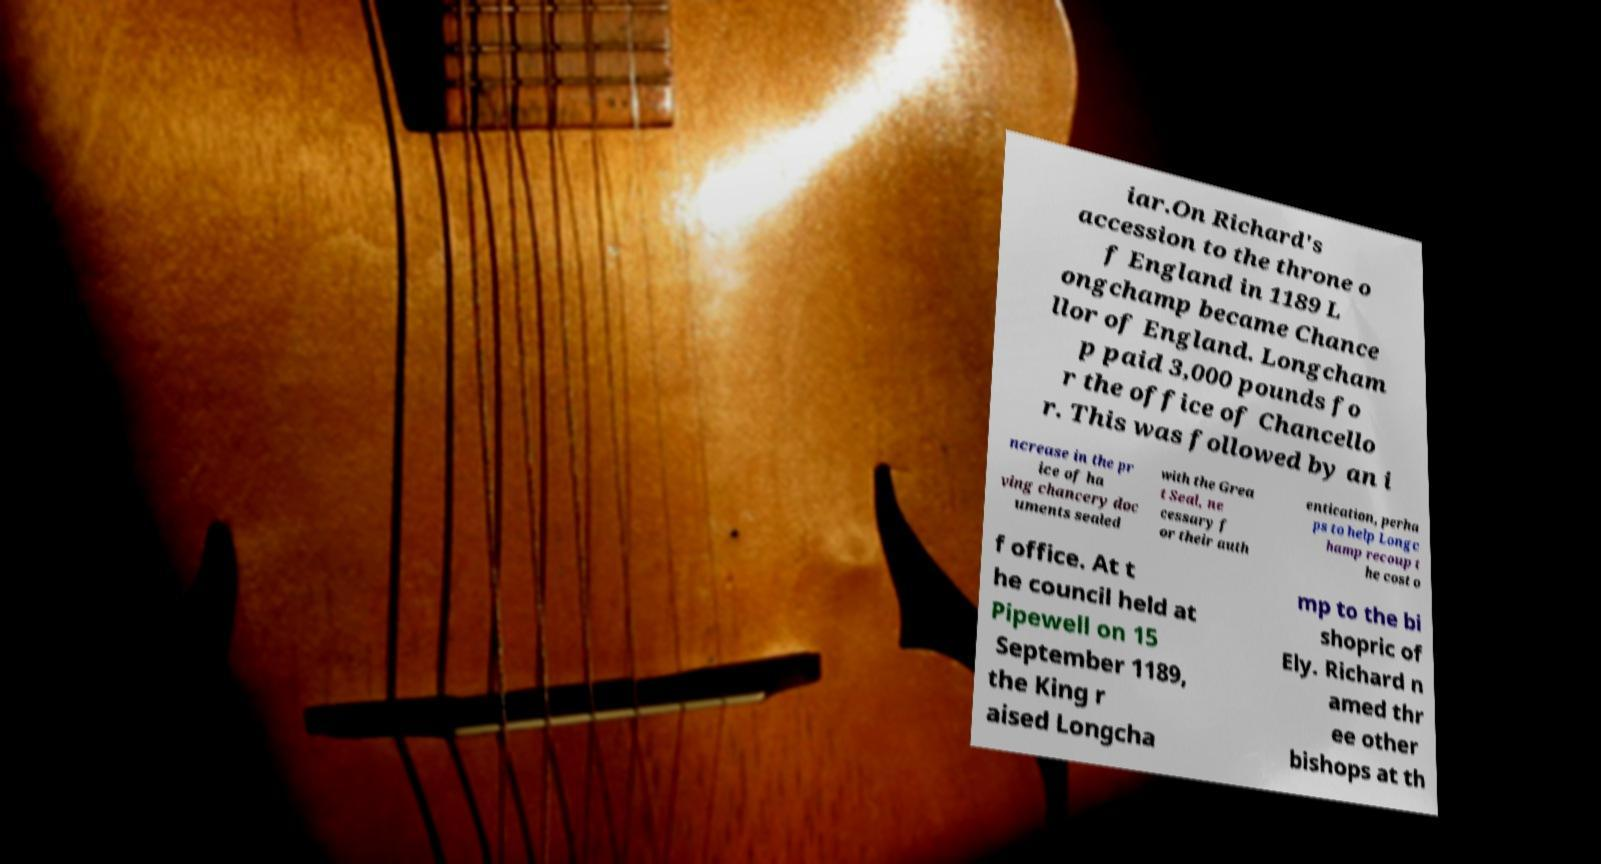Please identify and transcribe the text found in this image. iar.On Richard's accession to the throne o f England in 1189 L ongchamp became Chance llor of England. Longcham p paid 3,000 pounds fo r the office of Chancello r. This was followed by an i ncrease in the pr ice of ha ving chancery doc uments sealed with the Grea t Seal, ne cessary f or their auth entication, perha ps to help Longc hamp recoup t he cost o f office. At t he council held at Pipewell on 15 September 1189, the King r aised Longcha mp to the bi shopric of Ely. Richard n amed thr ee other bishops at th 